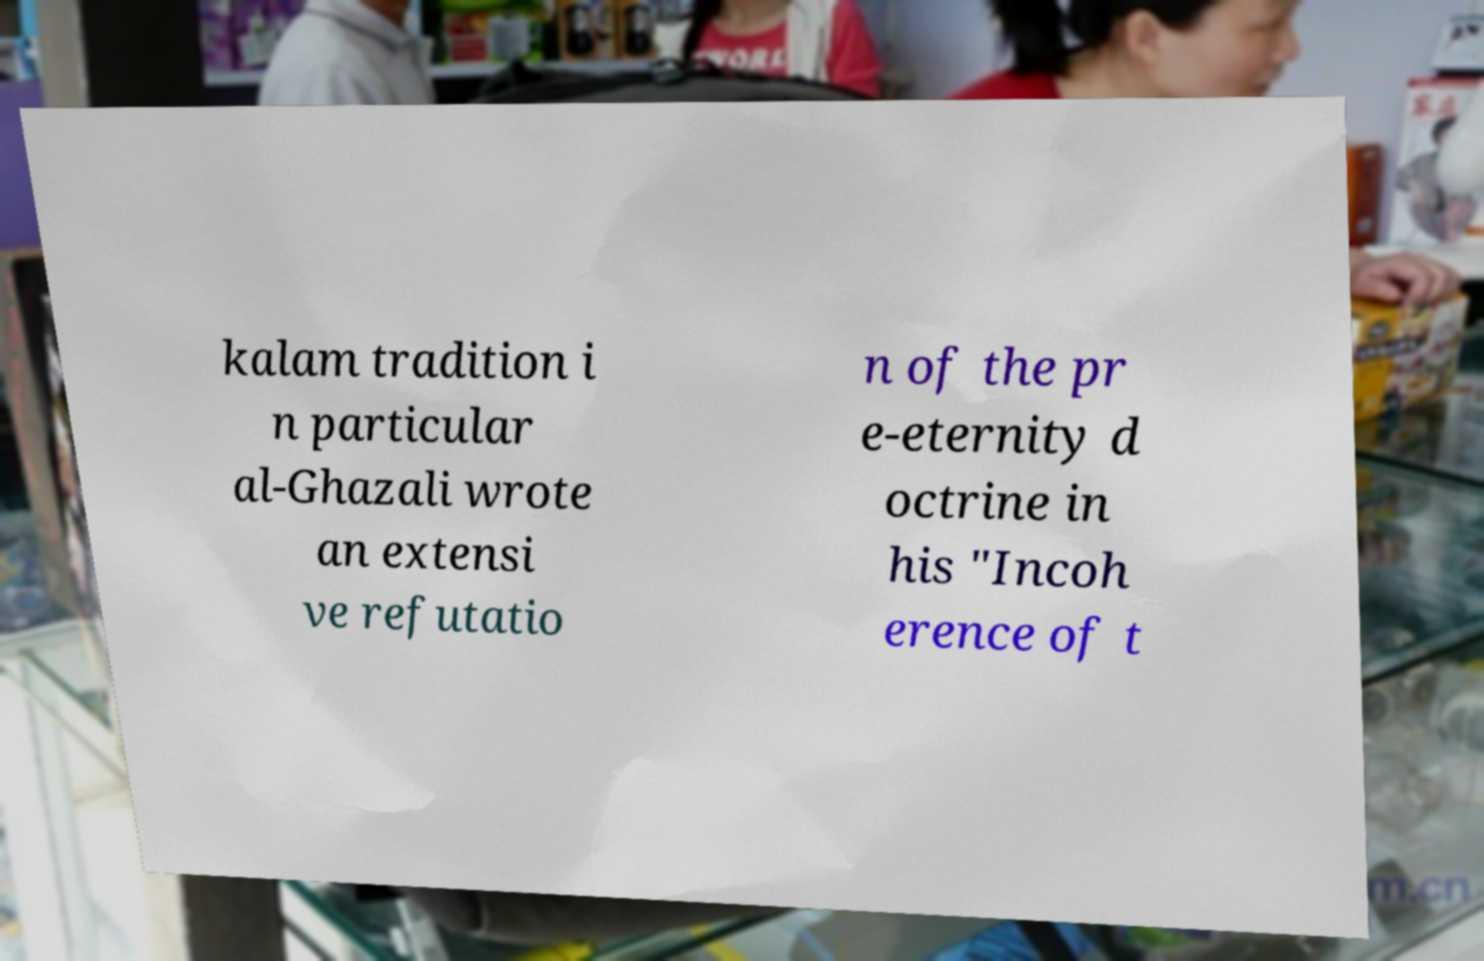Could you assist in decoding the text presented in this image and type it out clearly? kalam tradition i n particular al-Ghazali wrote an extensi ve refutatio n of the pr e-eternity d octrine in his "Incoh erence of t 